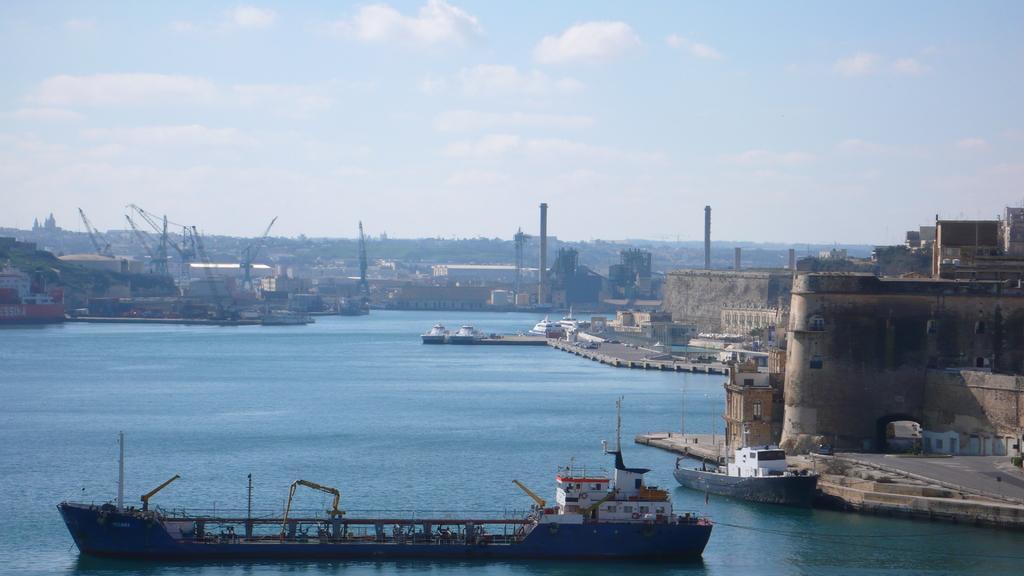Can you describe this image briefly? This image consists of boats. At the bottom, there is water. To the right, there is a wall. At the top, there are clouds in the sky. 